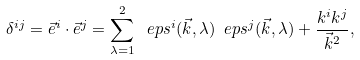<formula> <loc_0><loc_0><loc_500><loc_500>\delta ^ { i j } = \vec { e } ^ { i } \cdot \vec { e } ^ { j } = \sum _ { \lambda = 1 } ^ { 2 } \ e p s ^ { i } ( \vec { k } , \lambda ) \ e p s ^ { j } ( \vec { k } , \lambda ) + \frac { k ^ { i } k ^ { j } } { \vec { k } ^ { 2 } } ,</formula> 